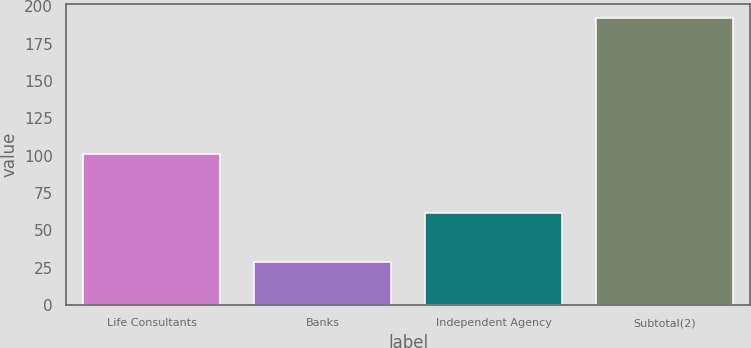Convert chart to OTSL. <chart><loc_0><loc_0><loc_500><loc_500><bar_chart><fcel>Life Consultants<fcel>Banks<fcel>Independent Agency<fcel>Subtotal(2)<nl><fcel>101<fcel>29<fcel>62<fcel>192<nl></chart> 